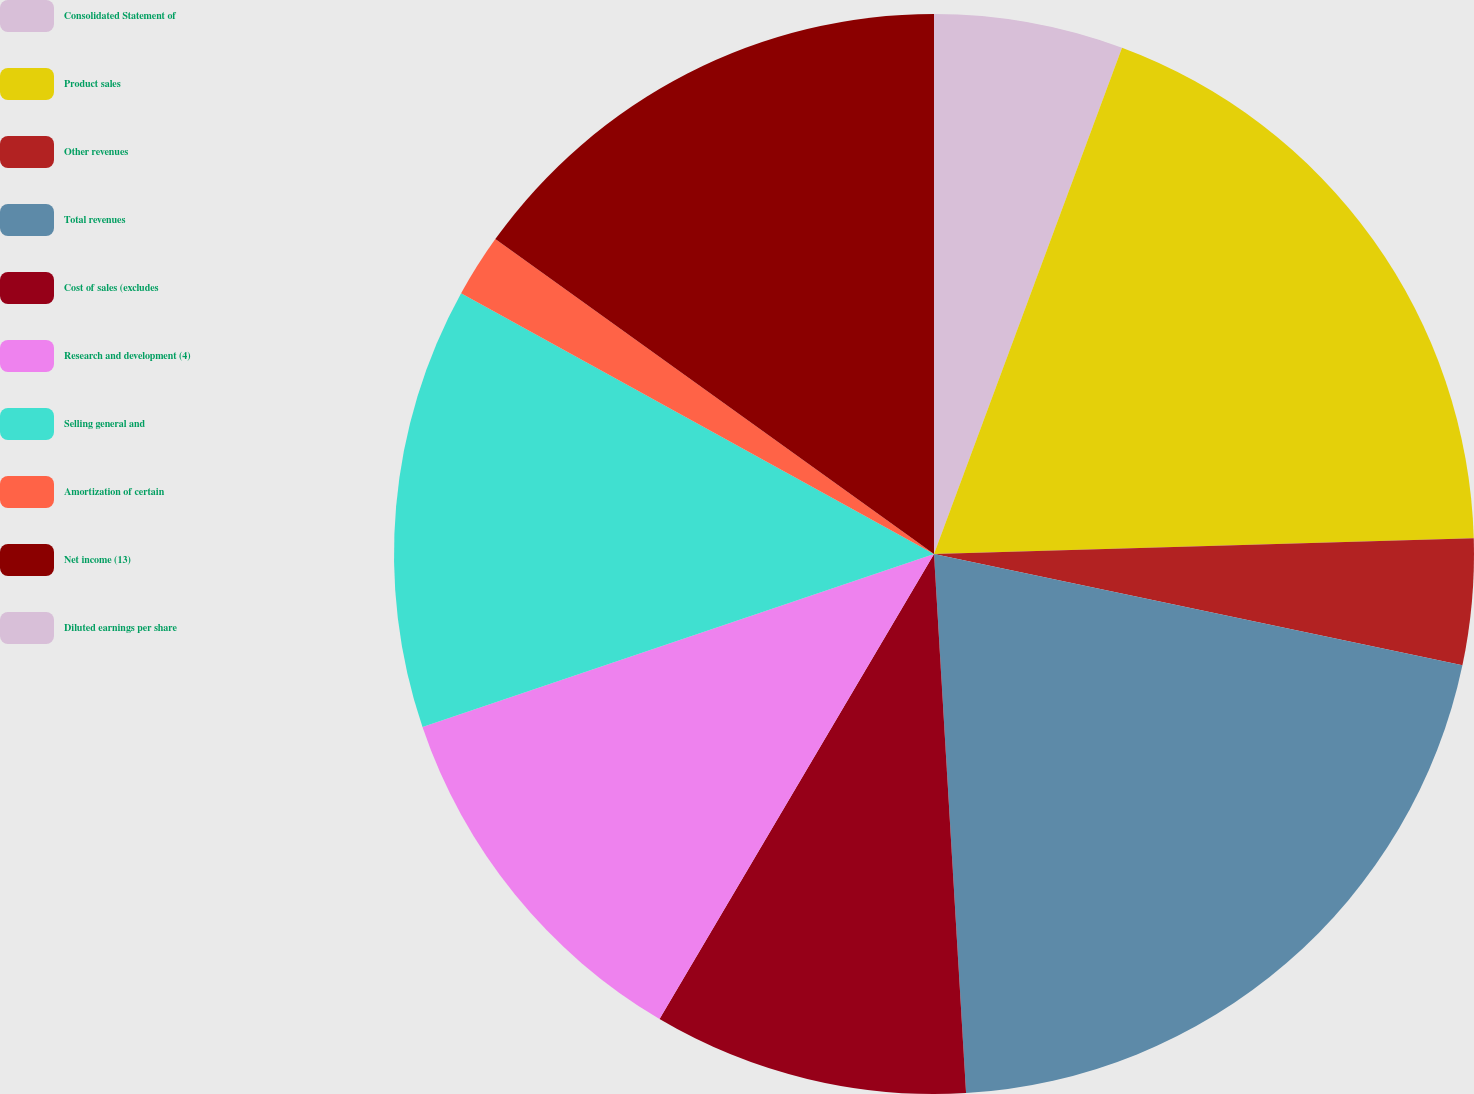<chart> <loc_0><loc_0><loc_500><loc_500><pie_chart><fcel>Consolidated Statement of<fcel>Product sales<fcel>Other revenues<fcel>Total revenues<fcel>Cost of sales (excludes<fcel>Research and development (4)<fcel>Selling general and<fcel>Amortization of certain<fcel>Net income (13)<fcel>Diluted earnings per share<nl><fcel>5.66%<fcel>18.87%<fcel>3.77%<fcel>20.75%<fcel>9.43%<fcel>11.32%<fcel>13.21%<fcel>1.89%<fcel>15.09%<fcel>0.0%<nl></chart> 